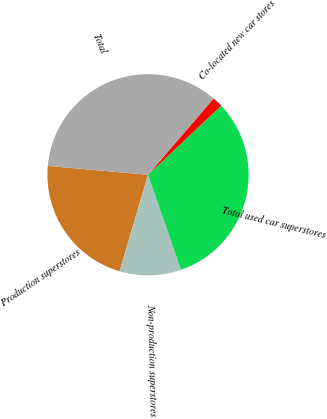<chart> <loc_0><loc_0><loc_500><loc_500><pie_chart><fcel>Production superstores<fcel>Non-production superstores<fcel>Total used car superstores<fcel>Co-located new car stores<fcel>Total<nl><fcel>21.84%<fcel>9.89%<fcel>31.73%<fcel>1.65%<fcel>34.9%<nl></chart> 